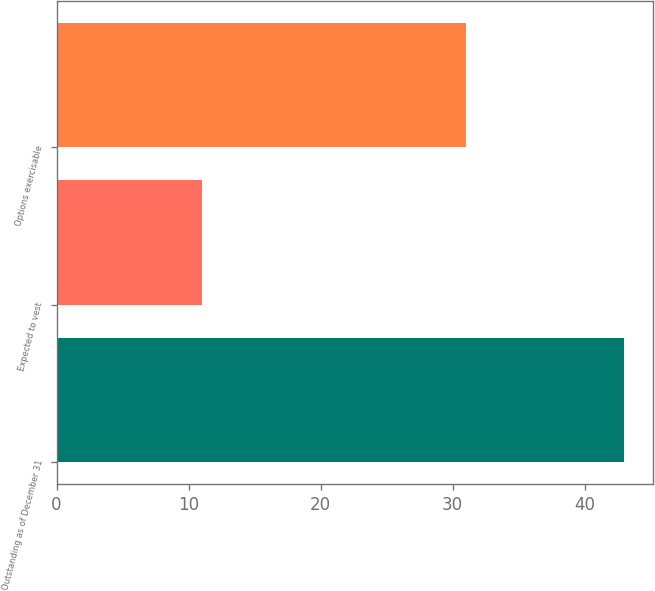Convert chart to OTSL. <chart><loc_0><loc_0><loc_500><loc_500><bar_chart><fcel>Outstanding as of December 31<fcel>Expected to vest<fcel>Options exercisable<nl><fcel>43<fcel>11<fcel>31<nl></chart> 